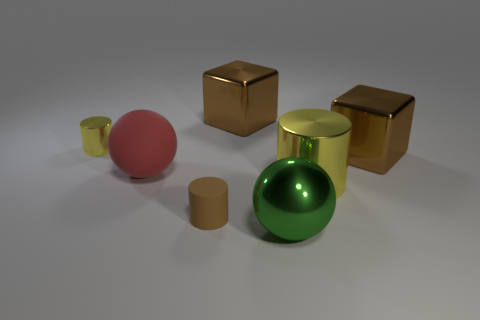Subtract all metallic cylinders. How many cylinders are left? 1 Add 2 yellow metal objects. How many objects exist? 9 Subtract 1 red balls. How many objects are left? 6 Subtract all cylinders. How many objects are left? 4 Subtract all blue things. Subtract all brown blocks. How many objects are left? 5 Add 2 brown blocks. How many brown blocks are left? 4 Add 5 tiny rubber cylinders. How many tiny rubber cylinders exist? 6 